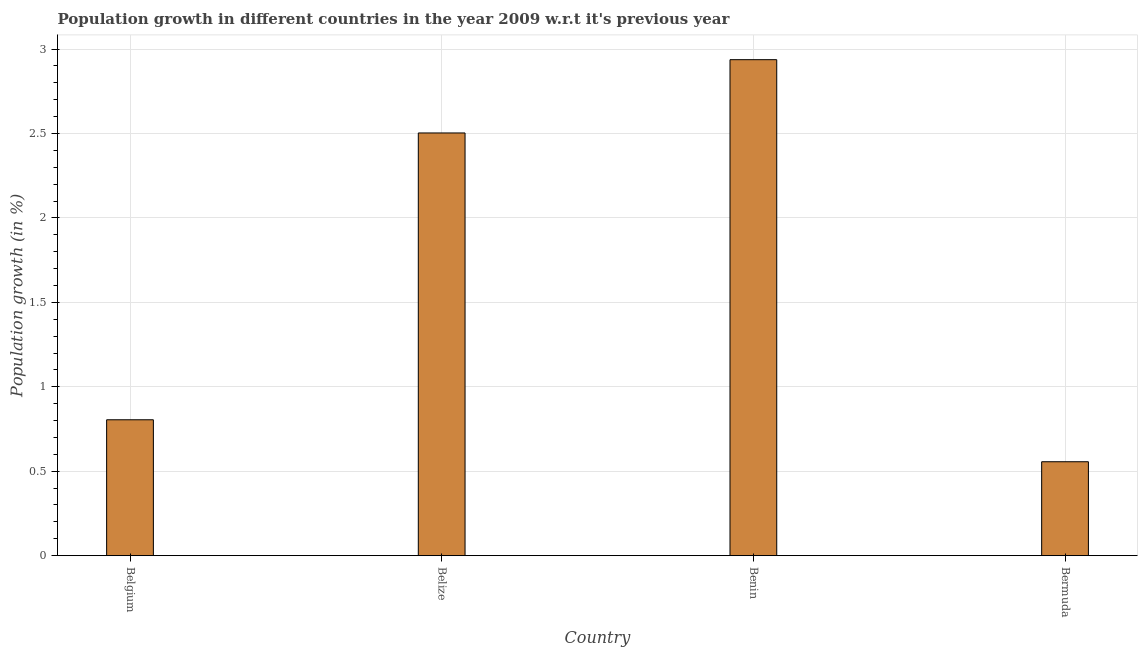Does the graph contain grids?
Offer a very short reply. Yes. What is the title of the graph?
Ensure brevity in your answer.  Population growth in different countries in the year 2009 w.r.t it's previous year. What is the label or title of the Y-axis?
Give a very brief answer. Population growth (in %). What is the population growth in Belgium?
Give a very brief answer. 0.8. Across all countries, what is the maximum population growth?
Your response must be concise. 2.94. Across all countries, what is the minimum population growth?
Your response must be concise. 0.56. In which country was the population growth maximum?
Provide a short and direct response. Benin. In which country was the population growth minimum?
Offer a very short reply. Bermuda. What is the sum of the population growth?
Give a very brief answer. 6.8. What is the difference between the population growth in Belgium and Bermuda?
Make the answer very short. 0.25. What is the median population growth?
Offer a very short reply. 1.65. What is the ratio of the population growth in Belize to that in Bermuda?
Give a very brief answer. 4.5. Is the population growth in Belgium less than that in Benin?
Offer a terse response. Yes. What is the difference between the highest and the second highest population growth?
Your answer should be very brief. 0.43. What is the difference between the highest and the lowest population growth?
Offer a terse response. 2.38. How many countries are there in the graph?
Make the answer very short. 4. What is the difference between two consecutive major ticks on the Y-axis?
Provide a short and direct response. 0.5. Are the values on the major ticks of Y-axis written in scientific E-notation?
Offer a terse response. No. What is the Population growth (in %) of Belgium?
Provide a short and direct response. 0.8. What is the Population growth (in %) of Belize?
Your answer should be very brief. 2.5. What is the Population growth (in %) in Benin?
Keep it short and to the point. 2.94. What is the Population growth (in %) of Bermuda?
Provide a short and direct response. 0.56. What is the difference between the Population growth (in %) in Belgium and Belize?
Provide a short and direct response. -1.7. What is the difference between the Population growth (in %) in Belgium and Benin?
Offer a very short reply. -2.13. What is the difference between the Population growth (in %) in Belgium and Bermuda?
Your response must be concise. 0.25. What is the difference between the Population growth (in %) in Belize and Benin?
Offer a terse response. -0.43. What is the difference between the Population growth (in %) in Belize and Bermuda?
Offer a terse response. 1.95. What is the difference between the Population growth (in %) in Benin and Bermuda?
Offer a terse response. 2.38. What is the ratio of the Population growth (in %) in Belgium to that in Belize?
Your response must be concise. 0.32. What is the ratio of the Population growth (in %) in Belgium to that in Benin?
Provide a succinct answer. 0.27. What is the ratio of the Population growth (in %) in Belgium to that in Bermuda?
Ensure brevity in your answer.  1.45. What is the ratio of the Population growth (in %) in Belize to that in Benin?
Your response must be concise. 0.85. What is the ratio of the Population growth (in %) in Belize to that in Bermuda?
Provide a short and direct response. 4.5. What is the ratio of the Population growth (in %) in Benin to that in Bermuda?
Make the answer very short. 5.28. 